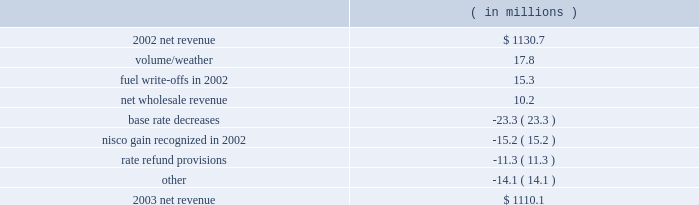Entergy gulf states , inc .
Management's financial discussion and analysis .
The volume/weather variance was due to higher electric sales volume in the service territory .
Billed usage increased a total of 517 gwh in the residential and commercial sectors .
The increase was partially offset by a decrease in industrial usage of 470 gwh due to the loss of two large industrial customers to cogeneration .
The customers accounted for approximately 1% ( 1 % ) of entergy gulf states' net revenue in 2002 .
In 2002 , deferred fuel costs of $ 8.9 million related to a texas fuel reconciliation case were written off and $ 6.5 million in expense resulted from an adjustment in the deregulated asset plan percentage as the result of a power uprate at river bend .
The increase in net wholesale revenue was primarily due to an increase in sales volume to municipal and co- op customers and also to affiliated systems related to entergy's generation resource planning .
The base rate decreases were effective june 2002 and january 2003 , both in the louisiana jurisdiction .
The january 2003 base rate decrease of $ 22.1 million had a minimal impact on net income due to a corresponding reduction in nuclear depreciation and decommissioning expenses associated with the change in accounting to reflect an assumed extension of river bend's useful life .
In 2002 , a gain of $ 15.2 million was recognized for the louisiana portion of the 1988 nelson units 1 and 2 sale .
Entergy gulf states received approval from the lpsc to discontinue applying amortization of the gain against recoverable fuel , resulting in the recognition of the deferred gain in income .
Rate refund provisions caused a decrease in net revenue due to additional provisions recorded in 2003 compared to 2002 for potential rate actions and refunds .
Gross operating revenues and fuel and purchased power expenses gross operating revenues increased primarily due to an increase of $ 440.2 million in fuel cost recovery revenues as a result of higher fuel rates in both the louisiana and texas jurisdictions .
Fuel and purchased power expenses increased $ 471.1 million due to an increase in the market prices of natural gas and purchased power .
Other income statement variances 2004 compared to 2003 other operation and maintenance expenses decreased primarily due to : 2022 voluntary severance program accruals of $ 22.5 million in 2003 ; and 2022 a decrease of $ 4.3 million in nuclear material and labor costs due to reduced staff in 2004. .
What were are the deferred fuel costs as a percentage of the total fuel write-offs in 2002? 
Computations: (8.9 / 15.3)
Answer: 0.5817. 